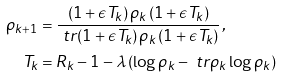Convert formula to latex. <formula><loc_0><loc_0><loc_500><loc_500>\rho _ { k + 1 } & = \frac { \left ( 1 + \epsilon T _ { k } \right ) \rho _ { k } \left ( 1 + \epsilon T _ { k } \right ) } { \ t r { \left ( 1 + \epsilon T _ { k } \right ) \rho _ { k } \left ( 1 + \epsilon T _ { k } \right ) } } \, , \\ T _ { k } & = R _ { k } - 1 - \lambda \left ( \log \rho _ { k } - \ t r { \rho _ { k } \log \rho _ { k } } \right ) \,</formula> 